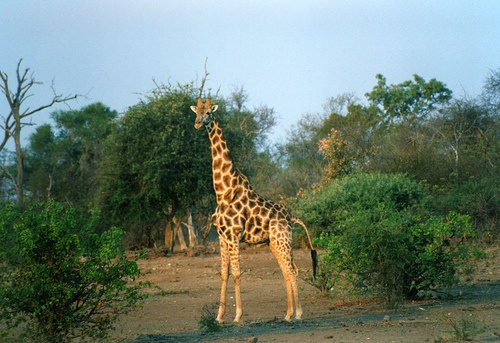Describe the objects in this image and their specific colors. I can see a giraffe in lightblue, tan, olive, and black tones in this image. 